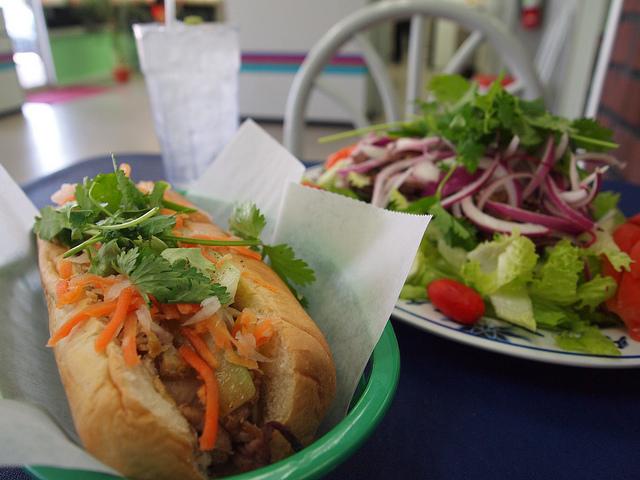What there ketchup on the table?
Keep it brief. No. How many sandwiches are there?
Answer briefly. 1. Is there meat in the meal?
Answer briefly. Yes. Is there a plate of salad?
Answer briefly. Yes. Has someone taken a bite from the top of the sandwich on the left?
Answer briefly. No. Is this a gluten free meal?
Answer briefly. No. 